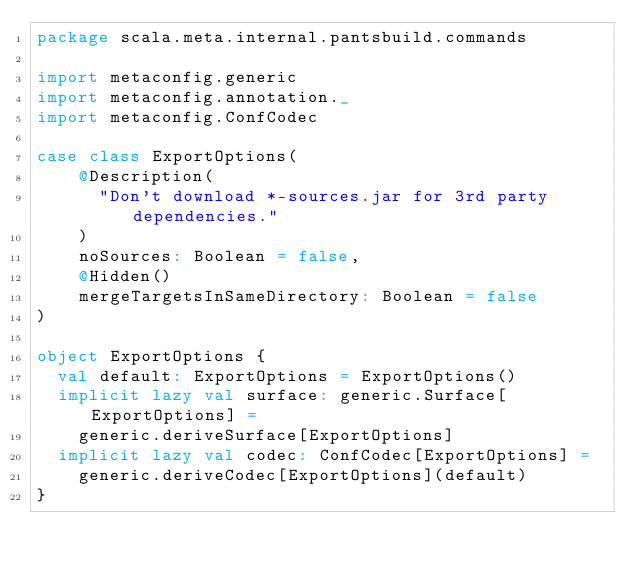Convert code to text. <code><loc_0><loc_0><loc_500><loc_500><_Scala_>package scala.meta.internal.pantsbuild.commands

import metaconfig.generic
import metaconfig.annotation._
import metaconfig.ConfCodec

case class ExportOptions(
    @Description(
      "Don't download *-sources.jar for 3rd party dependencies."
    )
    noSources: Boolean = false,
    @Hidden()
    mergeTargetsInSameDirectory: Boolean = false
)

object ExportOptions {
  val default: ExportOptions = ExportOptions()
  implicit lazy val surface: generic.Surface[ExportOptions] =
    generic.deriveSurface[ExportOptions]
  implicit lazy val codec: ConfCodec[ExportOptions] =
    generic.deriveCodec[ExportOptions](default)
}
</code> 